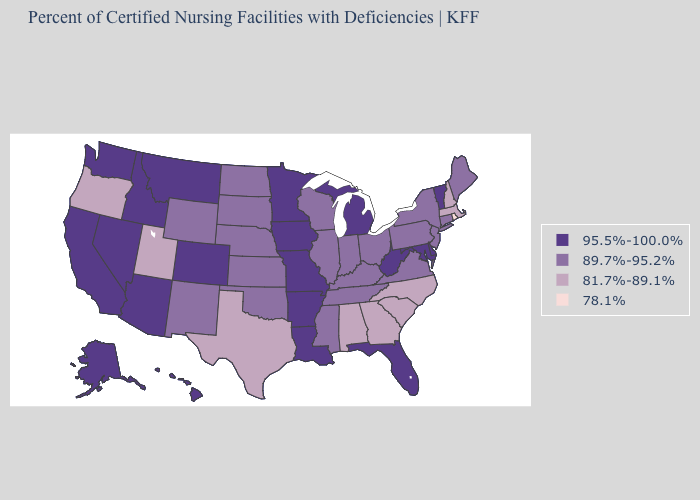What is the highest value in the South ?
Quick response, please. 95.5%-100.0%. Which states have the lowest value in the West?
Be succinct. Oregon, Utah. What is the value of South Dakota?
Answer briefly. 89.7%-95.2%. Does Nevada have the lowest value in the West?
Give a very brief answer. No. Does the map have missing data?
Write a very short answer. No. What is the value of Tennessee?
Write a very short answer. 89.7%-95.2%. Does the first symbol in the legend represent the smallest category?
Write a very short answer. No. What is the value of New Mexico?
Keep it brief. 89.7%-95.2%. Among the states that border Pennsylvania , which have the lowest value?
Quick response, please. New Jersey, New York, Ohio. Name the states that have a value in the range 89.7%-95.2%?
Keep it brief. Connecticut, Illinois, Indiana, Kansas, Kentucky, Maine, Mississippi, Nebraska, New Jersey, New Mexico, New York, North Dakota, Ohio, Oklahoma, Pennsylvania, South Dakota, Tennessee, Virginia, Wisconsin, Wyoming. Does Wyoming have a higher value than North Dakota?
Give a very brief answer. No. Among the states that border Arkansas , does Oklahoma have the lowest value?
Answer briefly. No. Does the first symbol in the legend represent the smallest category?
Keep it brief. No. What is the lowest value in the USA?
Give a very brief answer. 78.1%. 